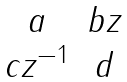Convert formula to latex. <formula><loc_0><loc_0><loc_500><loc_500>\begin{matrix} a & b z \\ c z ^ { - 1 } & d \end{matrix}</formula> 